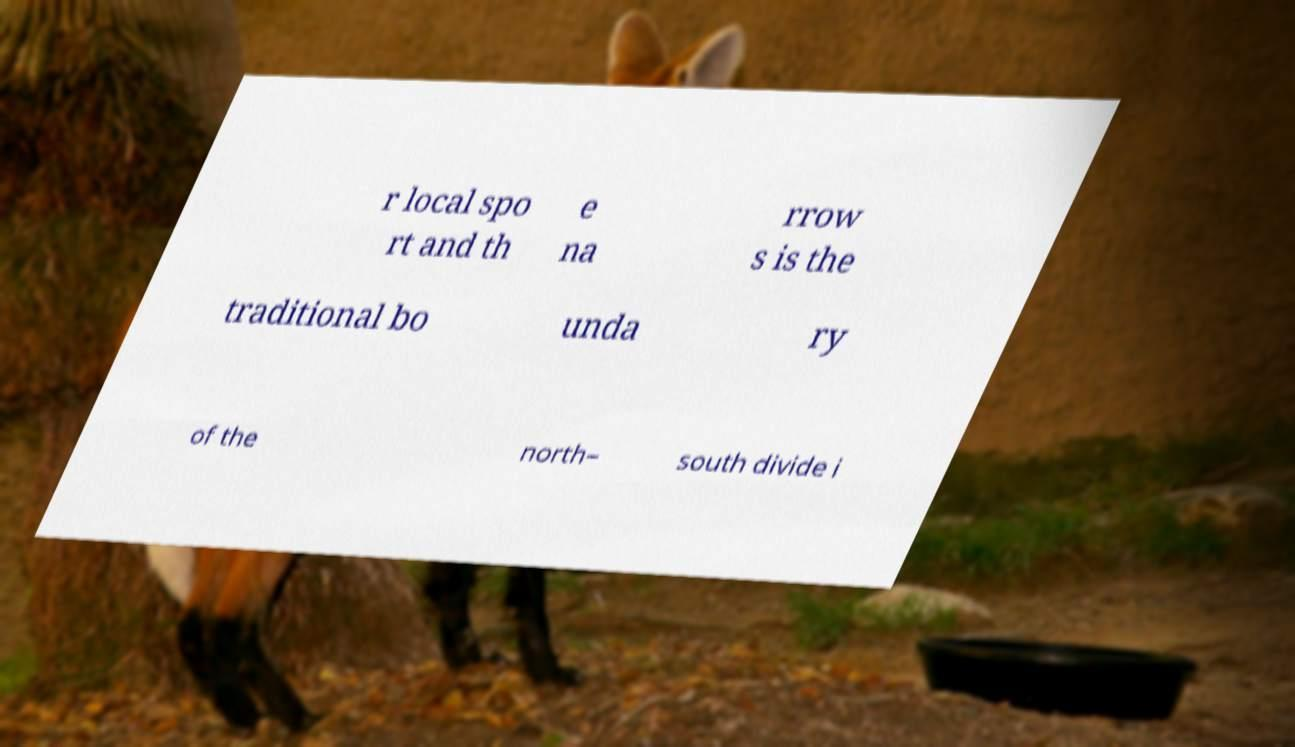Can you read and provide the text displayed in the image?This photo seems to have some interesting text. Can you extract and type it out for me? r local spo rt and th e na rrow s is the traditional bo unda ry of the north– south divide i 